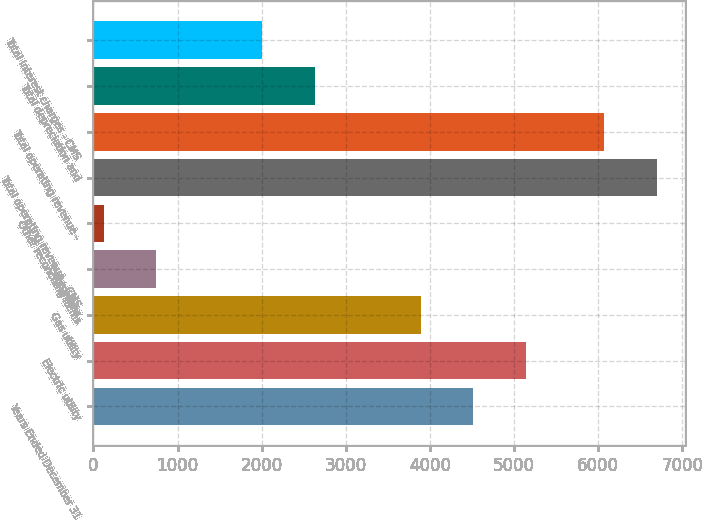<chart> <loc_0><loc_0><loc_500><loc_500><bar_chart><fcel>Years Ended December 31<fcel>Electric utility<fcel>Gas utility<fcel>Enterprises<fcel>Other reconciling items<fcel>Total operating revenue - CMS<fcel>Total operating revenue -<fcel>Total depreciation and<fcel>Total interest charges - CMS<nl><fcel>4515.3<fcel>5143.2<fcel>3887.4<fcel>747.9<fcel>120<fcel>6691.9<fcel>6064<fcel>2631.6<fcel>2003.7<nl></chart> 